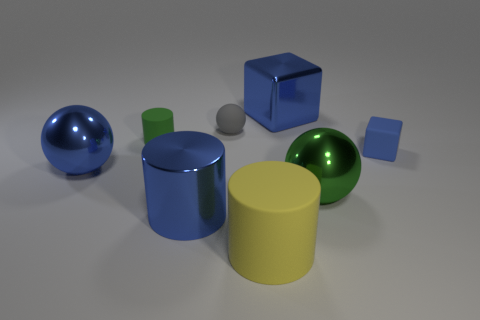How many big blue metal objects have the same shape as the small green rubber object?
Provide a succinct answer. 1. How many large things are cylinders or cyan shiny things?
Offer a terse response. 2. Is the color of the big sphere right of the blue cylinder the same as the large rubber object?
Offer a terse response. No. There is a shiny ball that is right of the blue ball; does it have the same color as the rubber object that is behind the tiny green cylinder?
Make the answer very short. No. Are there any tiny blue blocks made of the same material as the big yellow cylinder?
Your answer should be compact. Yes. How many red objects are either cylinders or tiny blocks?
Your answer should be compact. 0. Is the number of large yellow matte objects to the right of the big blue cylinder greater than the number of small matte balls?
Ensure brevity in your answer.  No. Is the size of the green cylinder the same as the green metallic ball?
Make the answer very short. No. There is a large cylinder that is made of the same material as the large green thing; what is its color?
Provide a succinct answer. Blue. There is a big thing that is the same color as the small rubber cylinder; what shape is it?
Your response must be concise. Sphere. 